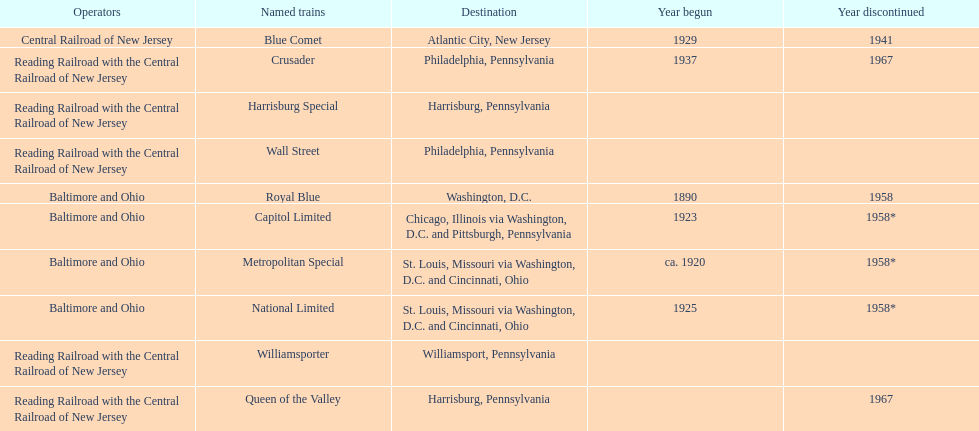What was the first train to begin service? Royal Blue. Would you be able to parse every entry in this table? {'header': ['Operators', 'Named trains', 'Destination', 'Year begun', 'Year discontinued'], 'rows': [['Central Railroad of New Jersey', 'Blue Comet', 'Atlantic City, New Jersey', '1929', '1941'], ['Reading Railroad with the Central Railroad of New Jersey', 'Crusader', 'Philadelphia, Pennsylvania', '1937', '1967'], ['Reading Railroad with the Central Railroad of New Jersey', 'Harrisburg Special', 'Harrisburg, Pennsylvania', '', ''], ['Reading Railroad with the Central Railroad of New Jersey', 'Wall Street', 'Philadelphia, Pennsylvania', '', ''], ['Baltimore and Ohio', 'Royal Blue', 'Washington, D.C.', '1890', '1958'], ['Baltimore and Ohio', 'Capitol Limited', 'Chicago, Illinois via Washington, D.C. and Pittsburgh, Pennsylvania', '1923', '1958*'], ['Baltimore and Ohio', 'Metropolitan Special', 'St. Louis, Missouri via Washington, D.C. and Cincinnati, Ohio', 'ca. 1920', '1958*'], ['Baltimore and Ohio', 'National Limited', 'St. Louis, Missouri via Washington, D.C. and Cincinnati, Ohio', '1925', '1958*'], ['Reading Railroad with the Central Railroad of New Jersey', 'Williamsporter', 'Williamsport, Pennsylvania', '', ''], ['Reading Railroad with the Central Railroad of New Jersey', 'Queen of the Valley', 'Harrisburg, Pennsylvania', '', '1967']]} 